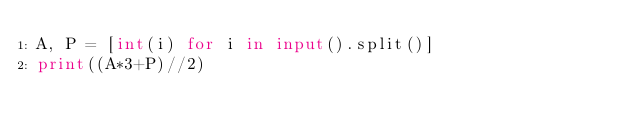Convert code to text. <code><loc_0><loc_0><loc_500><loc_500><_Python_>A, P = [int(i) for i in input().split()]
print((A*3+P)//2)</code> 